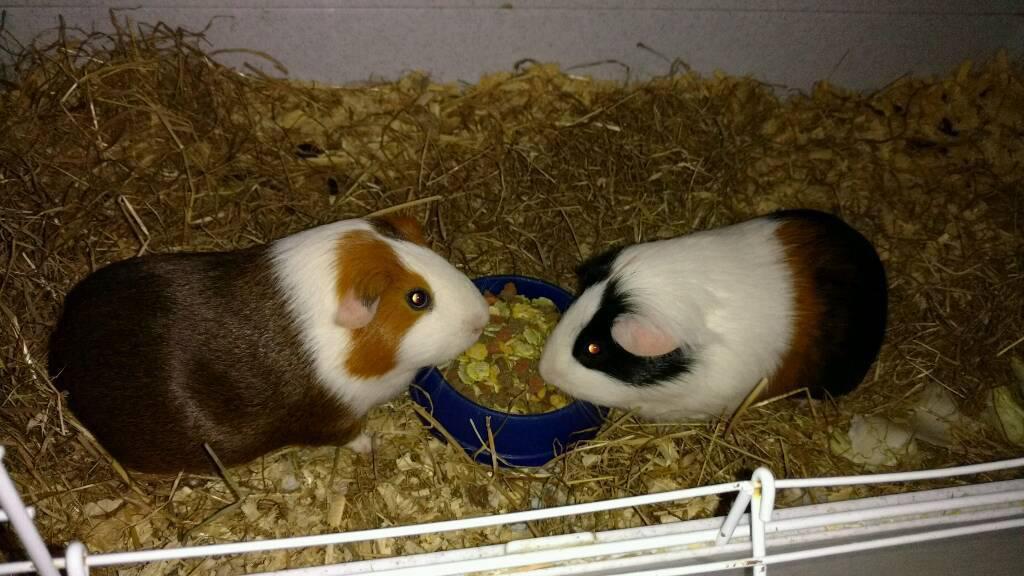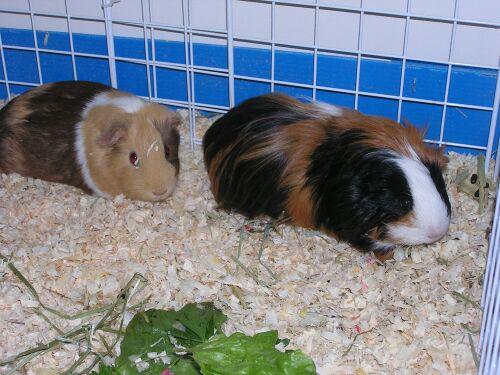The first image is the image on the left, the second image is the image on the right. Given the left and right images, does the statement "Each image shows two pet rodents on shredded-type bedding." hold true? Answer yes or no. Yes. 